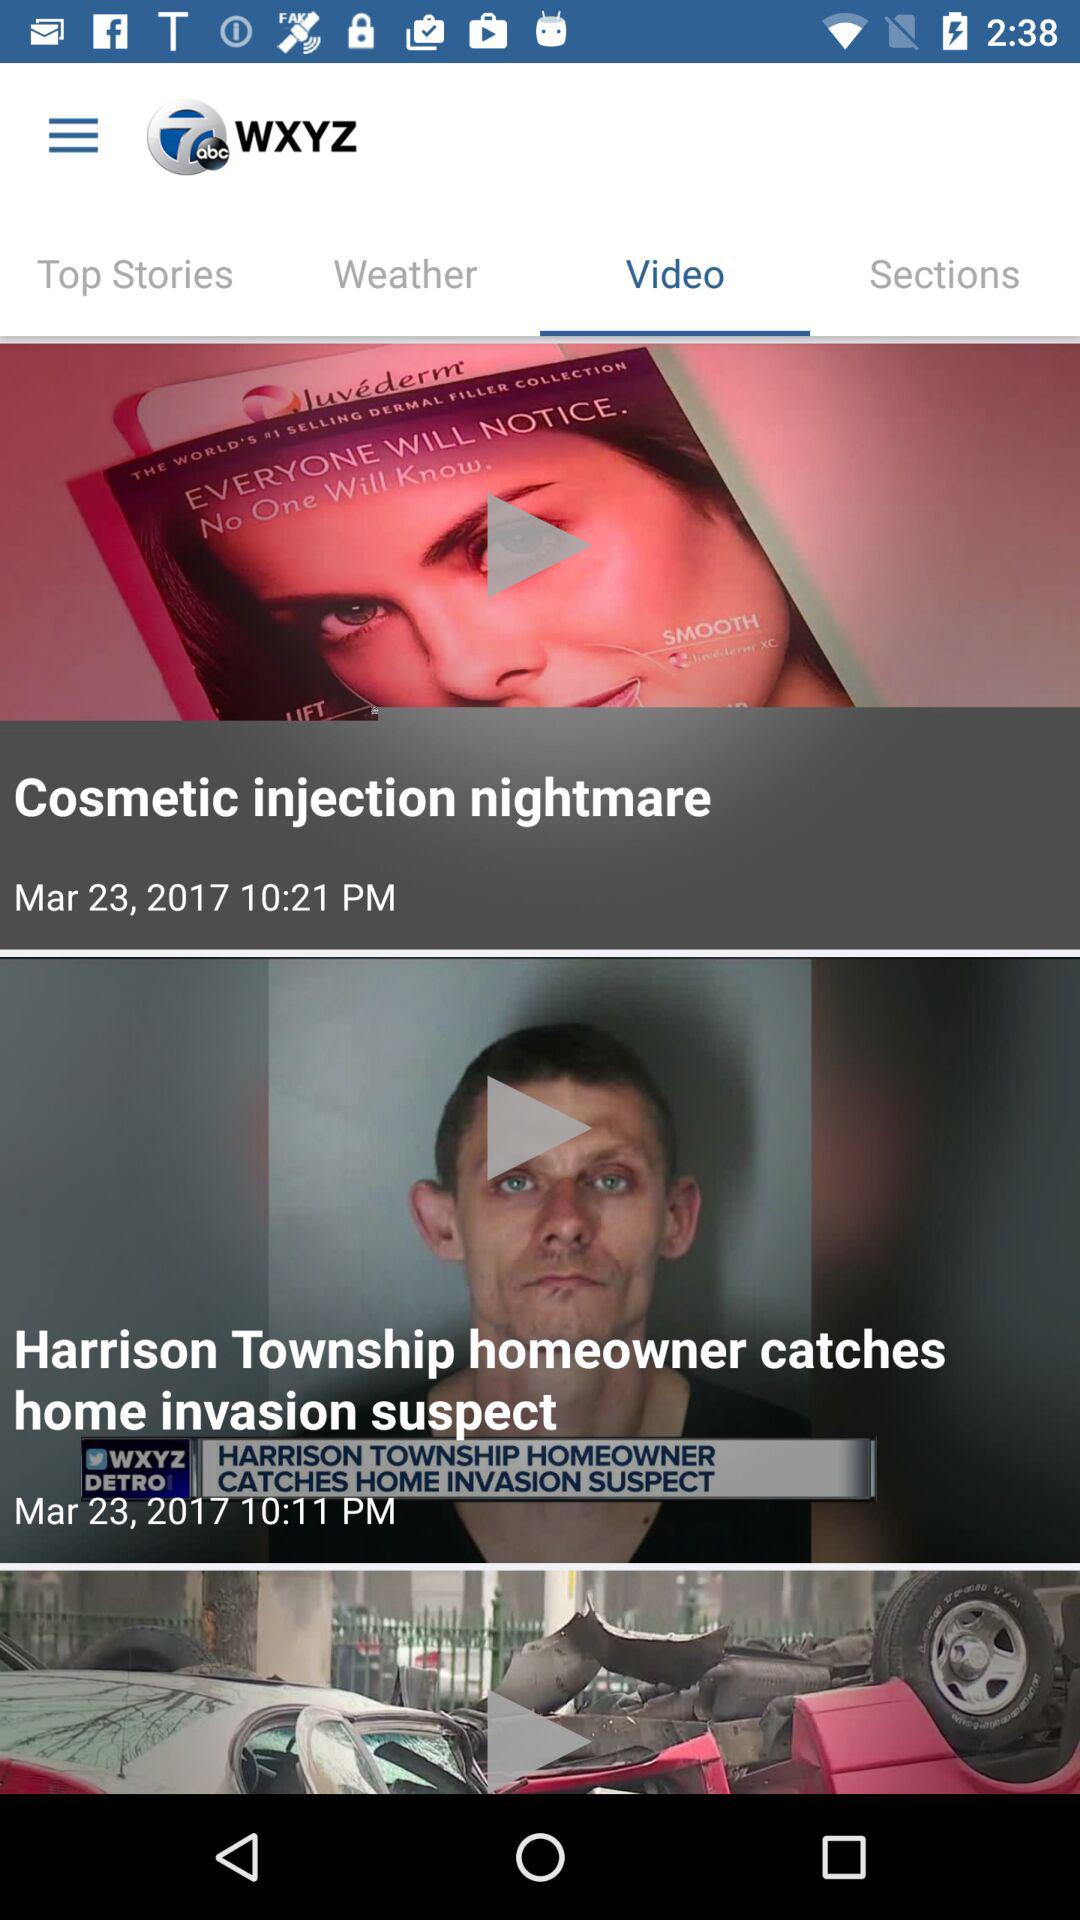Which tab am I using? You are using the "Video" tab. 